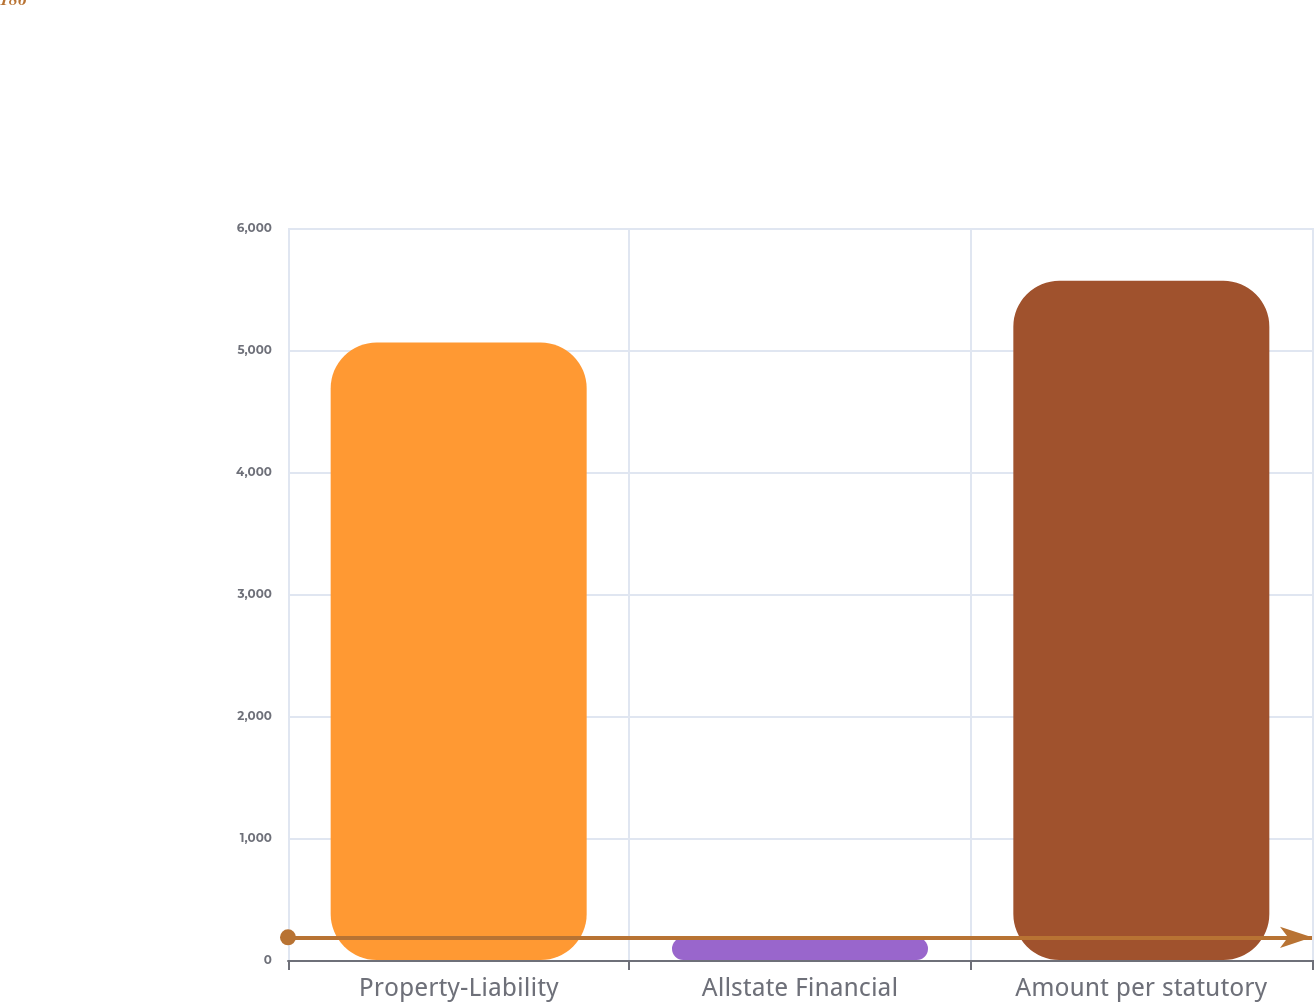<chart> <loc_0><loc_0><loc_500><loc_500><bar_chart><fcel>Property-Liability<fcel>Allstate Financial<fcel>Amount per statutory<nl><fcel>5062<fcel>186<fcel>5568.2<nl></chart> 